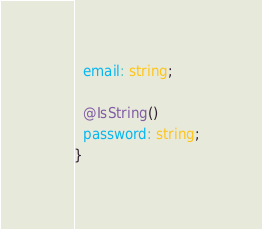<code> <loc_0><loc_0><loc_500><loc_500><_TypeScript_>  email: string;

  @IsString()
  password: string;
}
</code> 